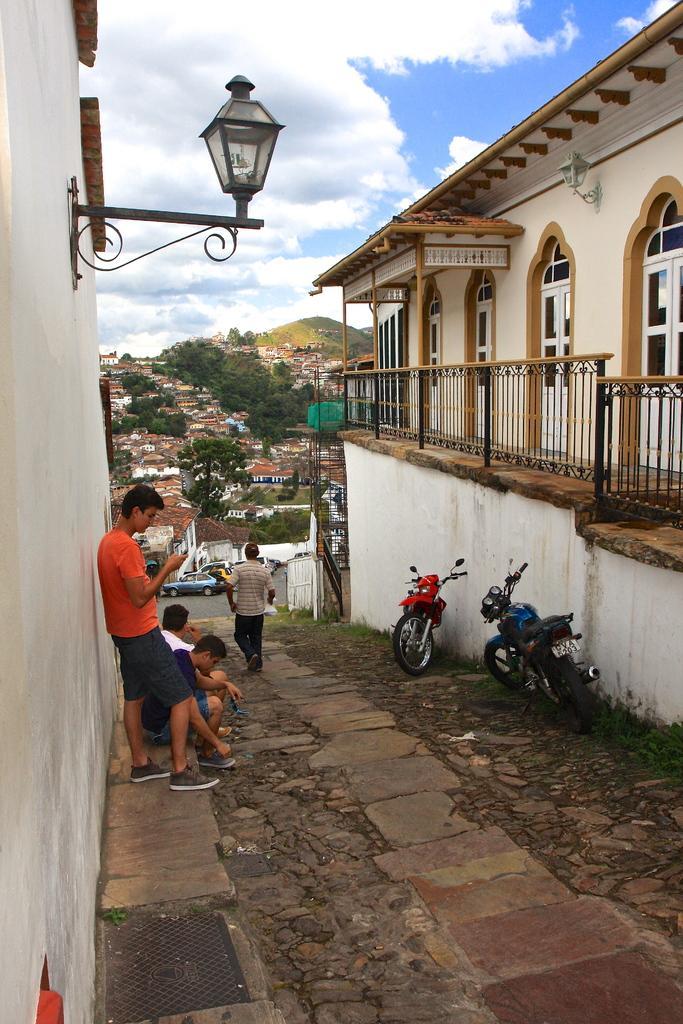Can you describe this image briefly? In this picture u we can describe about the beautiful view of the house lane. In front we can see boy wearing red color t-shirt and blue short standing and seeing in the phone. Beside we can see two boy sitting on the ground. Above we can see black color lamp post on the on wall. On the right side we can see two bikes are parked and a beautiful house with metal grill balcony and white color doors. 